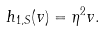Convert formula to latex. <formula><loc_0><loc_0><loc_500><loc_500>h _ { 1 , S } ( v ) = \eta ^ { 2 } v .</formula> 